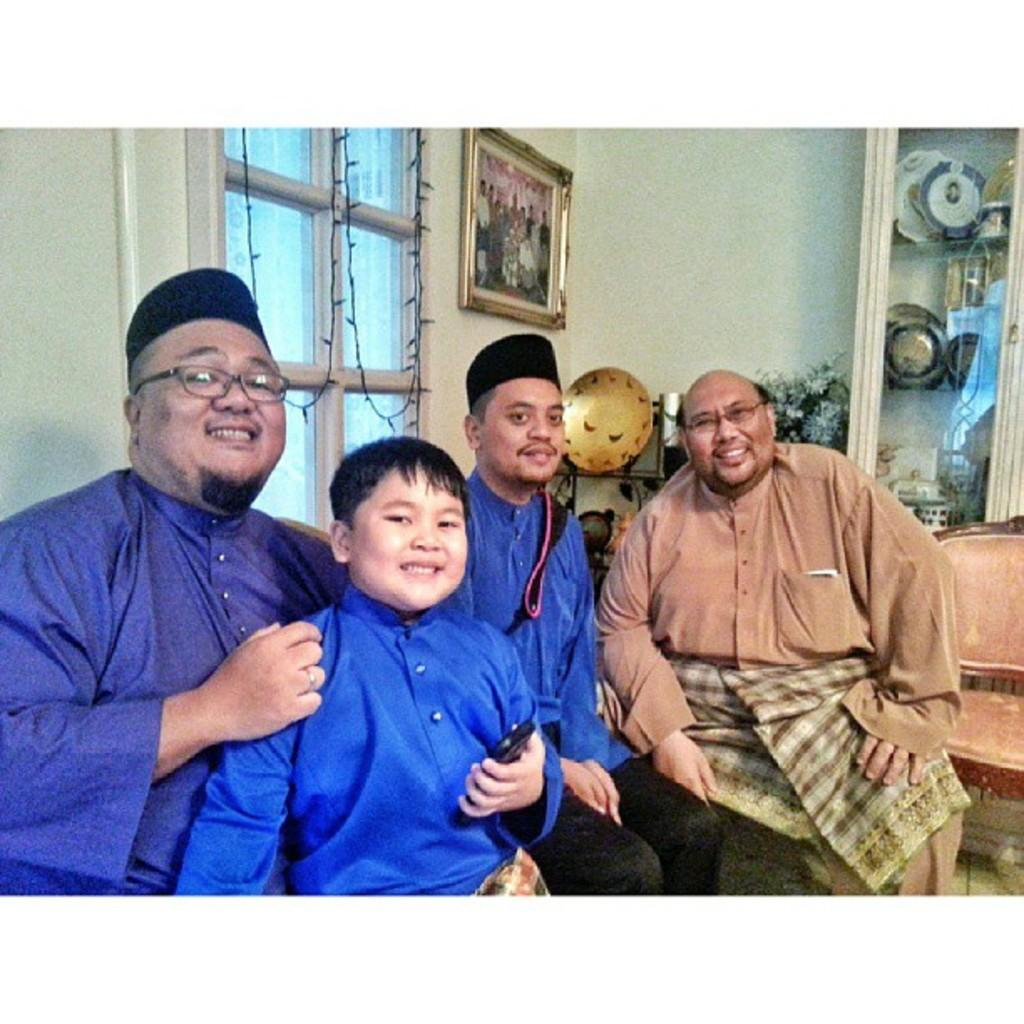What is the color of the wall in the image? The wall in the image is white. What can be seen on the wall in the image? There is a window and a photo frame on the wall in the image. What is located near the wall in the image? There is a plant and a rack in the image. What is on the rack in the image? There are plates on the rack in the image. What are the people in the image doing? The people in the image are sitting on chairs. How much money is being exchanged between the people in the image? There is no indication of money being exchanged between the people in the image. Can you describe the insect that is crawling on the plant in the image? There is no insect present on the plant in the image. 